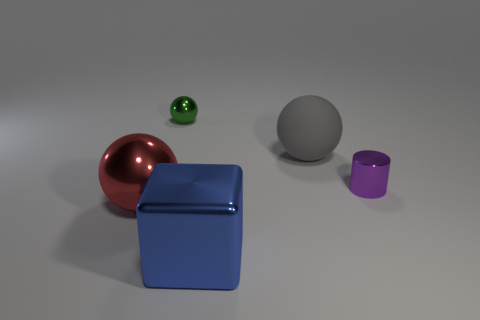How many other objects are there of the same material as the big blue thing?
Make the answer very short. 3. Is the size of the purple metal object the same as the sphere behind the gray object?
Offer a terse response. Yes. What is the color of the matte sphere?
Make the answer very short. Gray. The tiny metallic object that is in front of the shiny ball behind the large object that is behind the metal cylinder is what shape?
Provide a succinct answer. Cylinder. There is a object in front of the ball in front of the purple object; what is its material?
Your response must be concise. Metal. There is a large blue thing that is the same material as the cylinder; what shape is it?
Provide a short and direct response. Cube. Is there anything else that is the same shape as the small green object?
Keep it short and to the point. Yes. There is a small sphere; how many small objects are right of it?
Your response must be concise. 1. Are any large rubber spheres visible?
Your answer should be compact. Yes. What color is the metallic thing right of the big shiny object that is in front of the large object that is to the left of the big blue metallic cube?
Offer a very short reply. Purple. 